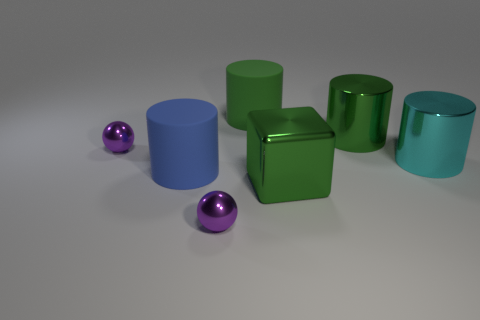The cylinder that is to the left of the purple thing that is right of the small object that is on the left side of the blue cylinder is made of what material?
Keep it short and to the point. Rubber. How many cylinders are large yellow rubber objects or small purple objects?
Your answer should be compact. 0. Are there any other things that have the same shape as the big cyan metal object?
Make the answer very short. Yes. Are there more things that are behind the big cyan thing than cylinders that are in front of the blue matte cylinder?
Your answer should be compact. Yes. What number of big matte cylinders are to the left of the large matte cylinder that is behind the cyan metal cylinder?
Provide a succinct answer. 1. What number of objects are large metal cubes or cyan objects?
Give a very brief answer. 2. What is the big cyan object made of?
Keep it short and to the point. Metal. How many objects are in front of the cyan cylinder and right of the large blue rubber cylinder?
Provide a succinct answer. 2. Does the green object to the left of the green metal cube have the same size as the cyan thing?
Ensure brevity in your answer.  Yes. What is the color of the tiny metal ball that is on the right side of the big blue matte cylinder?
Offer a terse response. Purple. 